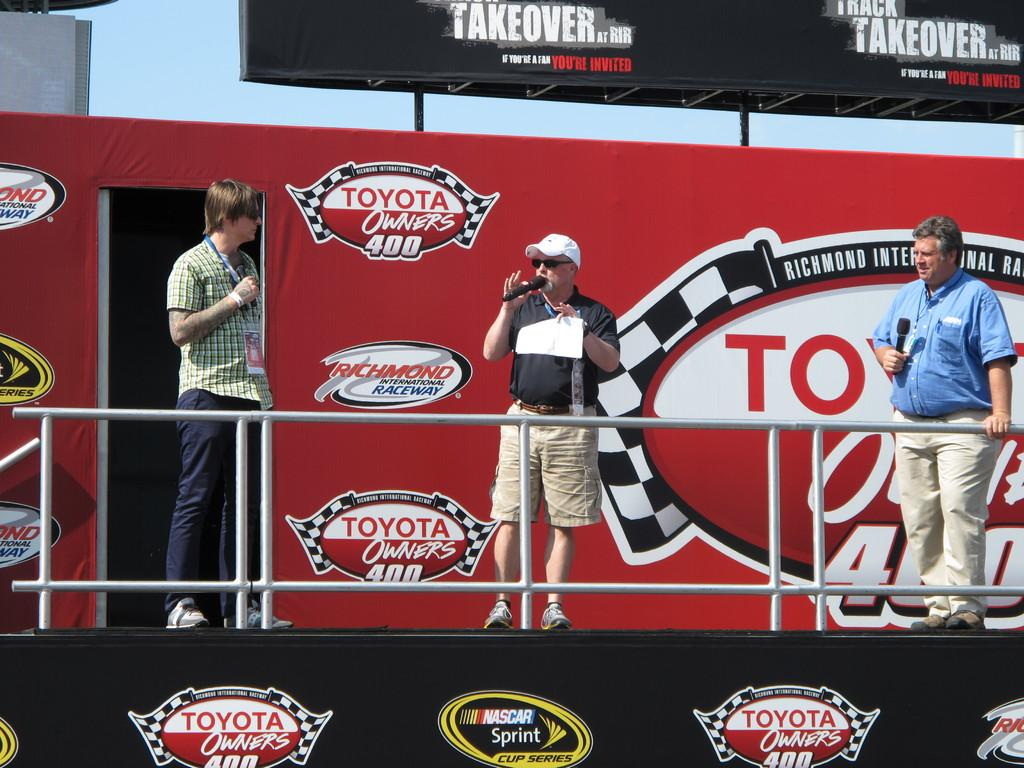Provide a one-sentence caption for the provided image. Three men stand on a platform of a structure bearing a logo for the Toyota Owner's 400 race. 